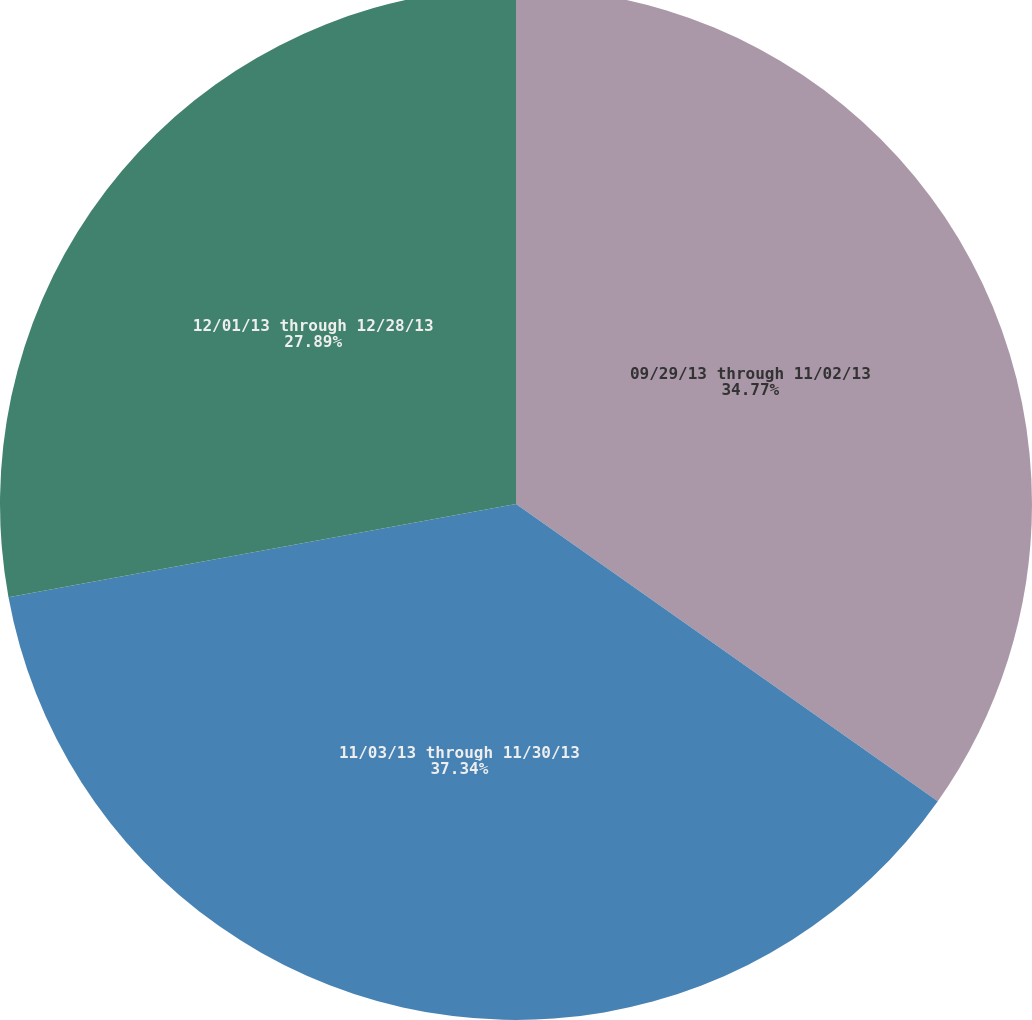Convert chart to OTSL. <chart><loc_0><loc_0><loc_500><loc_500><pie_chart><fcel>09/29/13 through 11/02/13<fcel>11/03/13 through 11/30/13<fcel>12/01/13 through 12/28/13<nl><fcel>34.77%<fcel>37.34%<fcel>27.89%<nl></chart> 